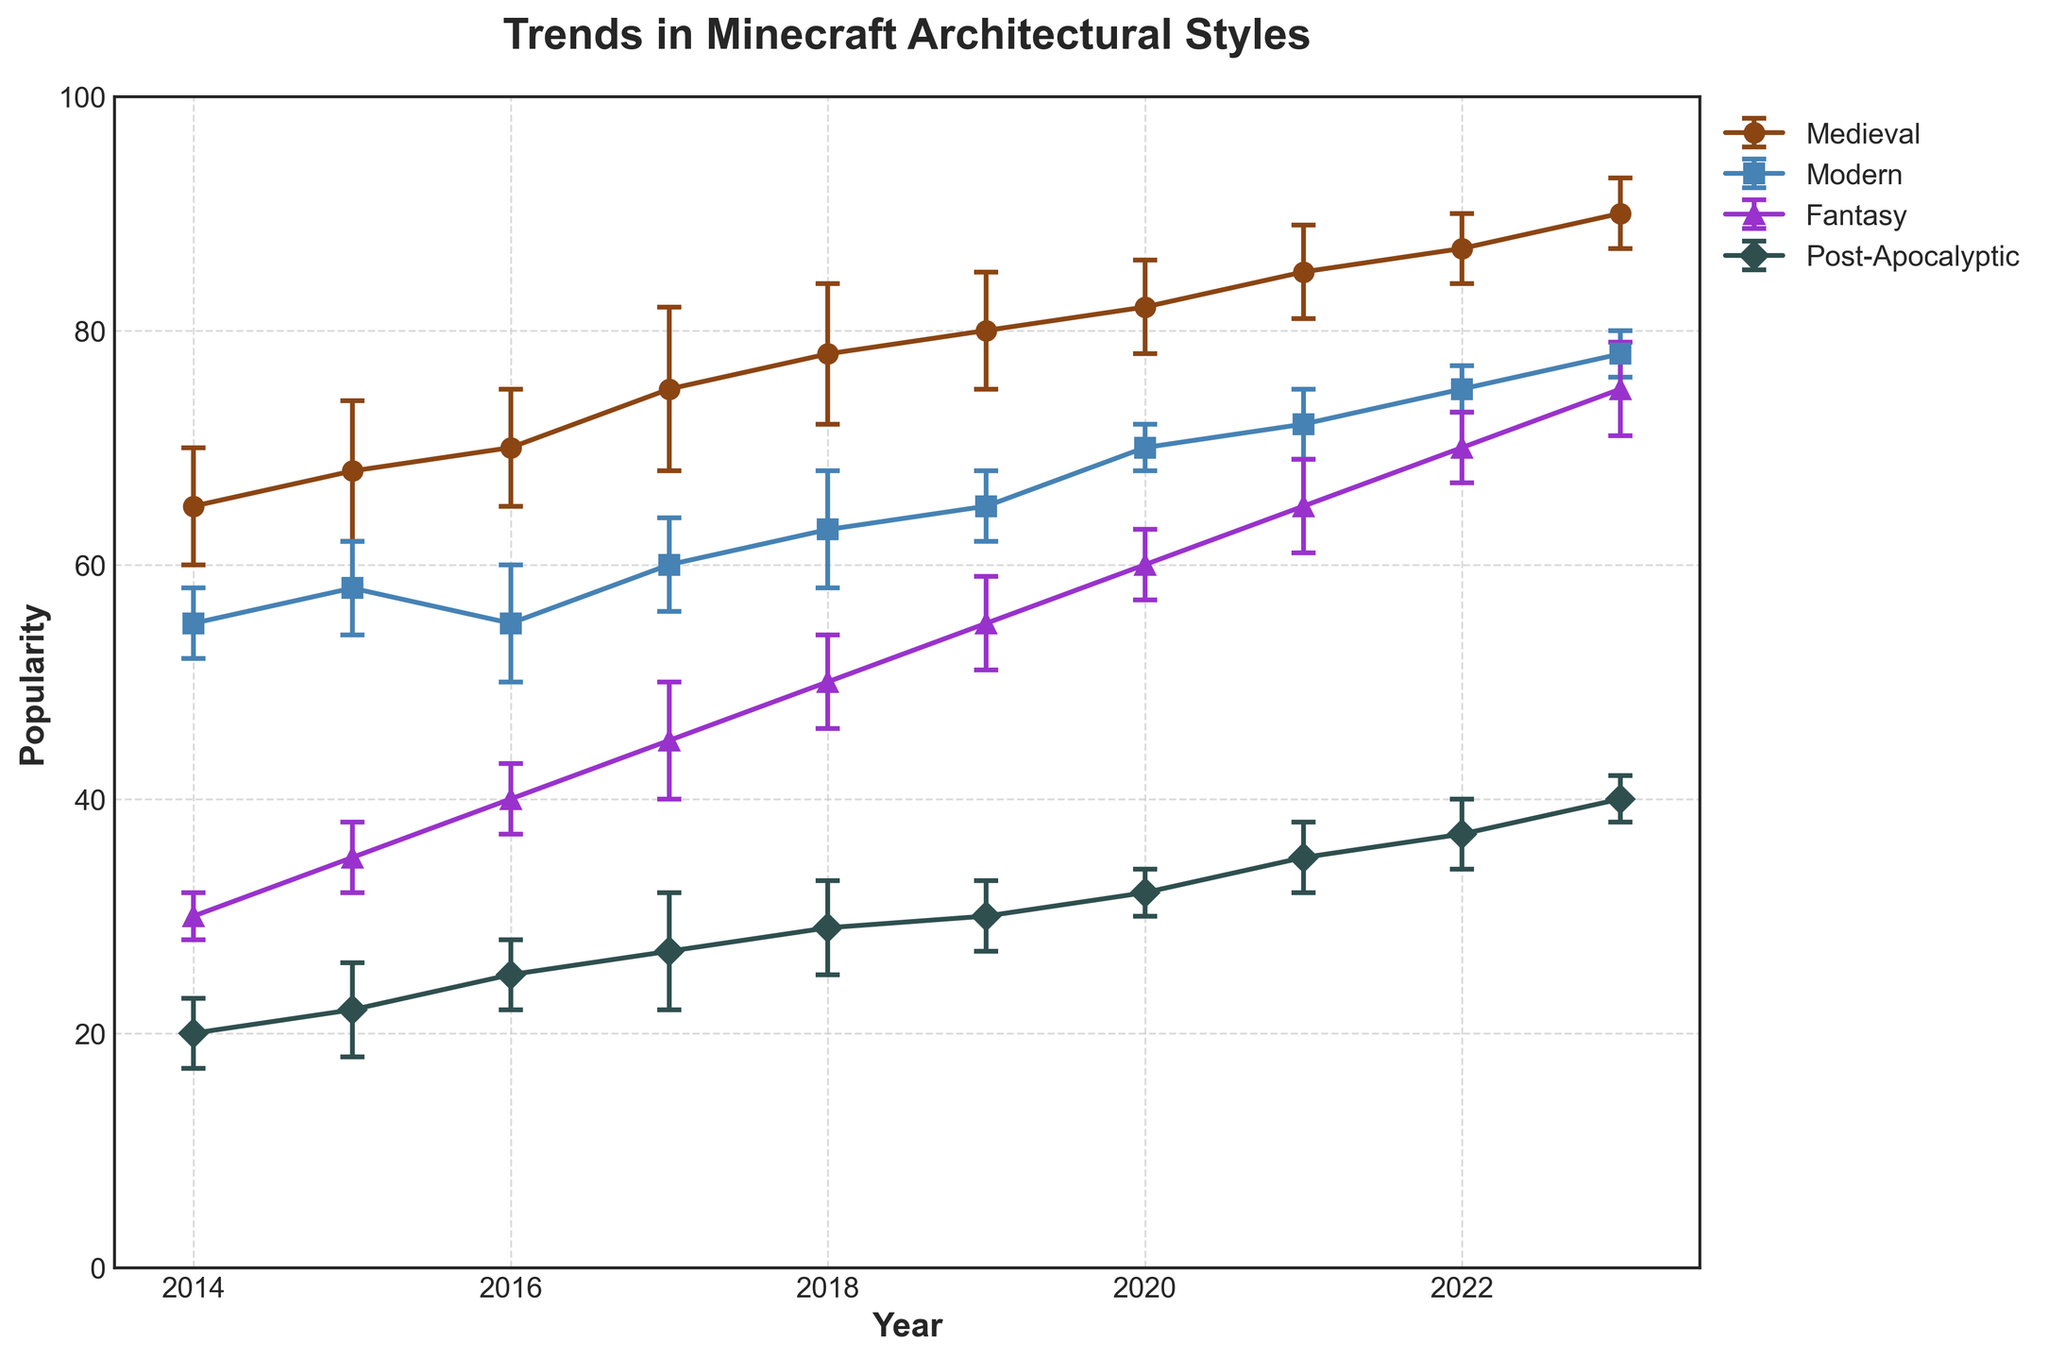What is the title of the figure? The title of the figure is written at the top and summarizes the overall content of the plot. Here, it reads "Trends in Minecraft Architectural Styles".
Answer: Trends in Minecraft Architectural Styles How many different architectural styles are represented in the plot? The plot uses different colored lines to represent different architectural styles. By examining the legend, we can see that there are four distinct styles listed.
Answer: Four Which architectural style had the highest popularity in 2023? By inspecting the end point of each line on the plot (the year 2023), we can compare the maximum values among the lines. Medieval has the highest value.
Answer: Medieval Which architectural style showed the greatest increase in popularity from 2014 to 2023? To determine this, look at the overall change in values from 2014 to 2023 for each style. Medieval increased from 65 to 90, Modern from 55 to 78, Fantasy from 30 to 75, and Post-Apocalyptic from 20 to 40. The greatest increase is for Fantasy.
Answer: Fantasy What is the maximum error range for Medieval style over the years provided? To find the maximum error range, look at the error bars for the Medieval style across all the years. The largest error bar is in 2017 with a value of 7.
Answer: 7 Which year saw the maximum popularity for the Modern style? The maximum value in the Modern line of the plot indicates the highest popularity. By tracking this line, the highest value, 78, occurs in 2023.
Answer: 2023 Compare the popularity trends of Fantasy and Post-Apocalyptic styles. Which one had a higher popularity in 2020, and by how much? In 2020, locate and compare the values for Fantasy and Post-Apocalyptic styles. Fantasy was at 60 and Post-Apocalyptic at 32. The difference is calculated as 60 - 32.
Answer: Fantasy, by 28 In which year did Modern and Post-Apocalyptic styles have the closest popularity values? By examining the lines and comparing their proximities each year, in 2016, Modern was at 55 and Post-Apocalyptic was at 25. No year has the popularity values closer than this.
Answer: 2016 What trend do you observe in the Medieval style's popularity from 2014 to 2023? By observing the Medieval line from 2014 to 2023, we see a consistent upward trend. The values steadily increase each year from 65 in 2014 to 90 in 2023.
Answer: Consistent upward trend What is the average popularity of the Modern style over the span of years provided? To find the average, sum all the popularity values for the Modern style from 2014 to 2023 and divide by the number of years: (55 + 58 + 55 + 60 + 63 + 65 + 70 + 72 + 75 + 78) / 10.
Answer: 65.1 